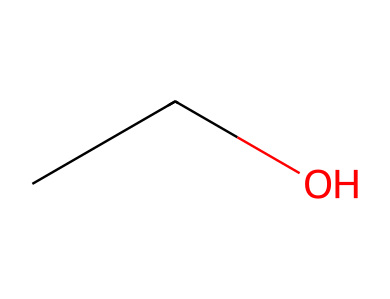How many carbon atoms are in this molecule? The SMILES representation "CCO" indicates there are two "C" letters, which represent carbon atoms in the structure.
Answer: two What is the name of this chemical? The structure represented by "CCO" corresponds to ethanol, which is a common solvent in perfumes and colognes.
Answer: ethanol How many hydrogen atoms are in this molecule? The two carbon atoms in ethanol each typically bond with three hydrogen atoms but are bonded to one of the carbons, resulting in five total hydrogens (three from one carbon and two from the other).
Answer: six What type of functional group is present in this compound? The presence of the hydroxyl group (-OH) indicated by the "O" at the end of "CCO" identifies it as an alcohol.
Answer: alcohol Is this molecule polar or non-polar? The presence of the hydroxyl group (-OH) creates an uneven distribution of charge, making the molecule polar due to the ability to form hydrogen bonds.
Answer: polar What is the degree of unsaturation in this molecule? Since ethanol does not contain any double or triple bonds nor rings, it has a degree of unsaturation of zero.
Answer: zero Can ethanol act as a refrigerant? Ethanol can absorb heat in the vaporization process, although its effectiveness as a refrigerant is not optimal compared to traditional refrigerants.
Answer: no 